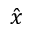Convert formula to latex. <formula><loc_0><loc_0><loc_500><loc_500>\hat { x }</formula> 